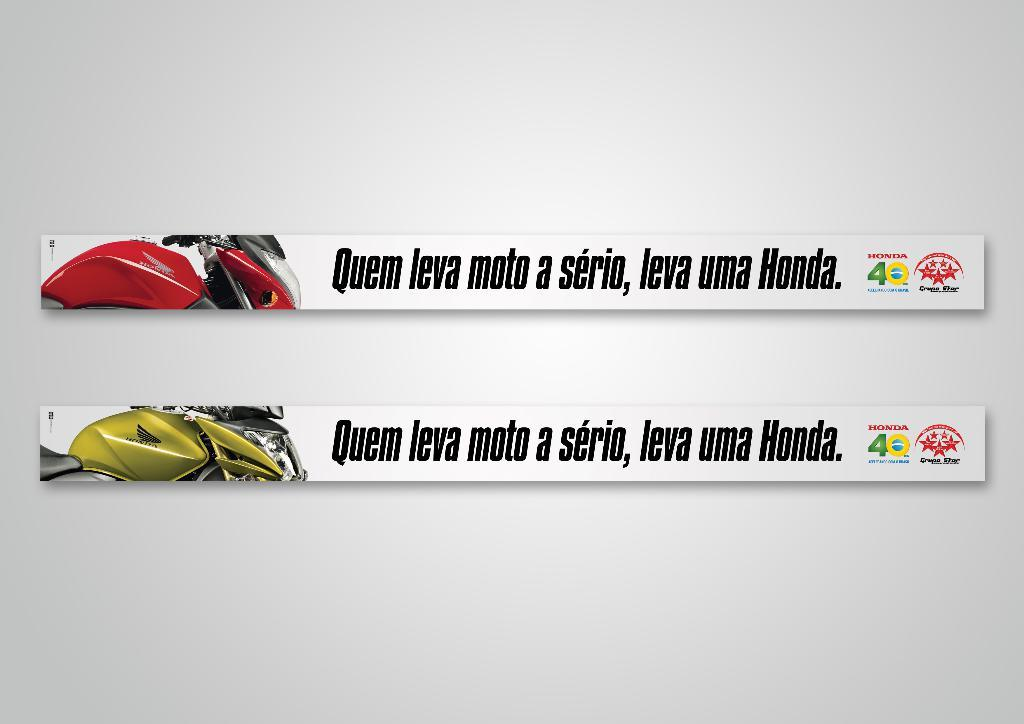What is on the white wall in the image? There are boards on a white wall in the image. What is depicted on the boards? Motorbikes are depicted on the boards. What colors are the motorbikes? The motorbikes are in red and green colors. Are there any words on the boards? Yes, names are written on the boards. How does the stop sign affect the motorbikes in the image? There is no stop sign present in the image, so its effect on the motorbikes cannot be determined. What happens when the motorbikes need to crush the obstacles in the image? There are no obstacles present in the image for the motorbikes to crush. 